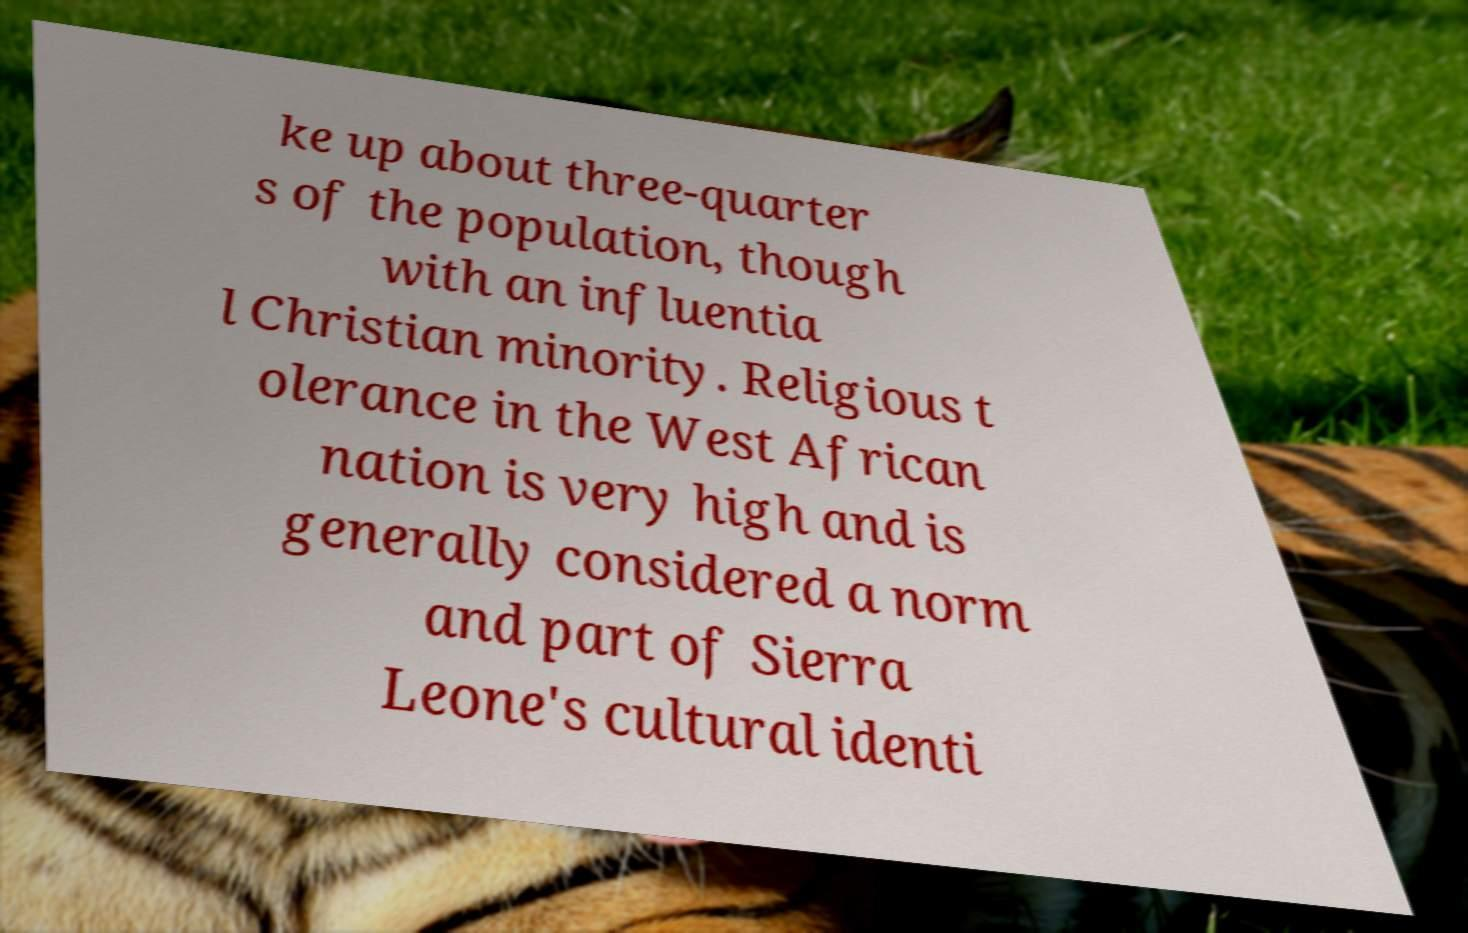Could you extract and type out the text from this image? ke up about three-quarter s of the population, though with an influentia l Christian minority. Religious t olerance in the West African nation is very high and is generally considered a norm and part of Sierra Leone's cultural identi 